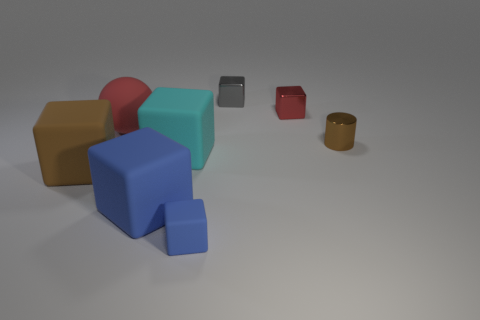Subtract all big cyan matte cubes. How many cubes are left? 5 Add 1 tiny metal balls. How many objects exist? 9 Subtract 2 blocks. How many blocks are left? 4 Subtract all cyan cubes. How many cubes are left? 5 Add 2 tiny brown objects. How many tiny brown objects are left? 3 Add 7 large cyan cubes. How many large cyan cubes exist? 8 Subtract 1 red cubes. How many objects are left? 7 Subtract all cubes. How many objects are left? 2 Subtract all green cylinders. Subtract all gray blocks. How many cylinders are left? 1 Subtract all purple balls. How many blue cubes are left? 2 